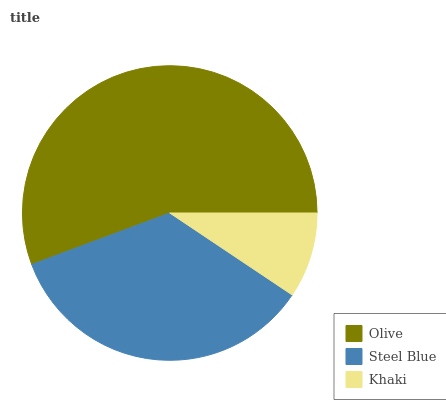Is Khaki the minimum?
Answer yes or no. Yes. Is Olive the maximum?
Answer yes or no. Yes. Is Steel Blue the minimum?
Answer yes or no. No. Is Steel Blue the maximum?
Answer yes or no. No. Is Olive greater than Steel Blue?
Answer yes or no. Yes. Is Steel Blue less than Olive?
Answer yes or no. Yes. Is Steel Blue greater than Olive?
Answer yes or no. No. Is Olive less than Steel Blue?
Answer yes or no. No. Is Steel Blue the high median?
Answer yes or no. Yes. Is Steel Blue the low median?
Answer yes or no. Yes. Is Khaki the high median?
Answer yes or no. No. Is Khaki the low median?
Answer yes or no. No. 